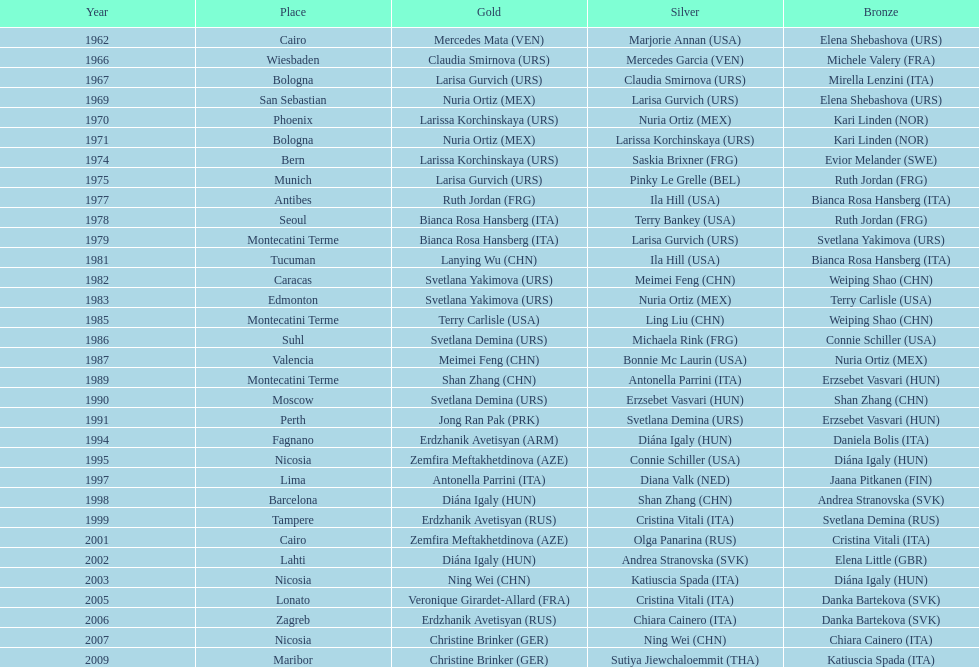Which nation possesses the highest number of bronze medals? Italy. 